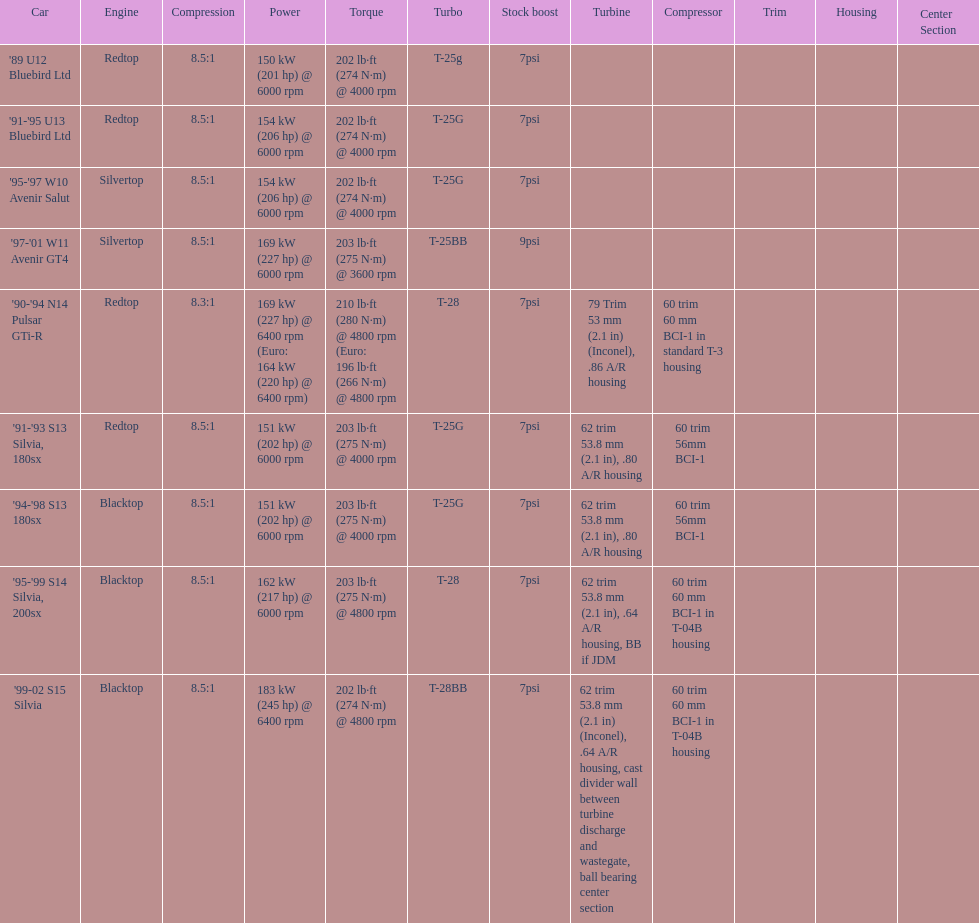What is his/her compression for the 90-94 n14 pulsar gti-r? 8.3:1. 